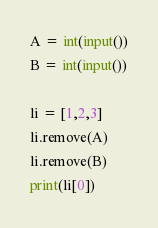Convert code to text. <code><loc_0><loc_0><loc_500><loc_500><_Python_>A = int(input())
B = int(input())

li = [1,2,3]
li.remove(A)
li.remove(B)
print(li[0])</code> 